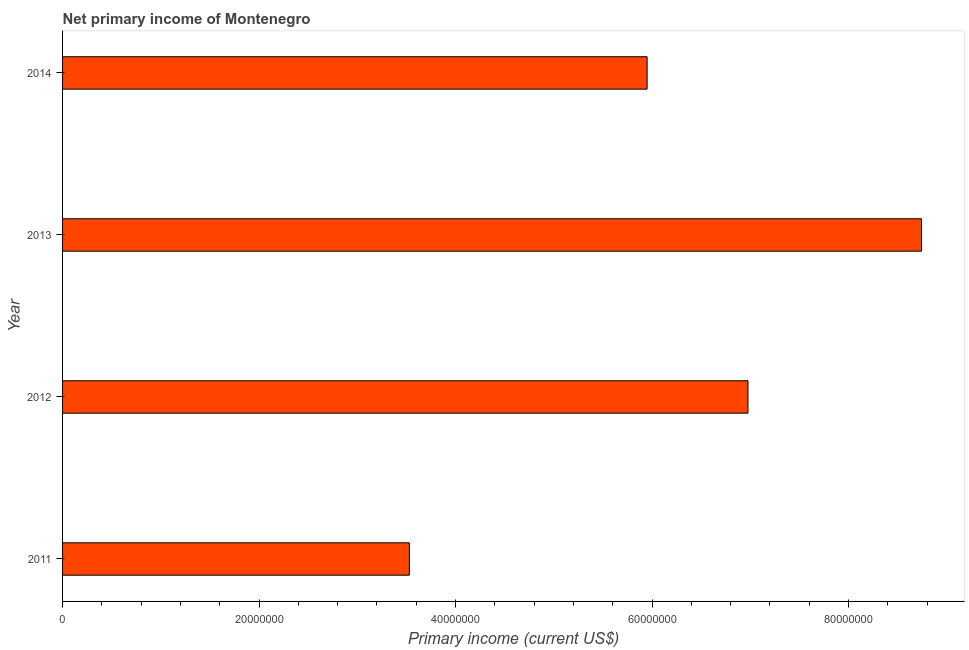What is the title of the graph?
Make the answer very short. Net primary income of Montenegro. What is the label or title of the X-axis?
Ensure brevity in your answer.  Primary income (current US$). What is the label or title of the Y-axis?
Make the answer very short. Year. What is the amount of primary income in 2013?
Give a very brief answer. 8.74e+07. Across all years, what is the maximum amount of primary income?
Your answer should be very brief. 8.74e+07. Across all years, what is the minimum amount of primary income?
Provide a succinct answer. 3.53e+07. What is the sum of the amount of primary income?
Offer a very short reply. 2.52e+08. What is the difference between the amount of primary income in 2012 and 2013?
Give a very brief answer. -1.77e+07. What is the average amount of primary income per year?
Provide a succinct answer. 6.30e+07. What is the median amount of primary income?
Keep it short and to the point. 6.46e+07. Do a majority of the years between 2013 and 2012 (inclusive) have amount of primary income greater than 68000000 US$?
Your response must be concise. No. What is the ratio of the amount of primary income in 2011 to that in 2012?
Offer a terse response. 0.51. Is the amount of primary income in 2011 less than that in 2014?
Provide a short and direct response. Yes. What is the difference between the highest and the second highest amount of primary income?
Offer a terse response. 1.77e+07. Is the sum of the amount of primary income in 2011 and 2013 greater than the maximum amount of primary income across all years?
Your response must be concise. Yes. What is the difference between the highest and the lowest amount of primary income?
Your response must be concise. 5.21e+07. What is the difference between two consecutive major ticks on the X-axis?
Provide a short and direct response. 2.00e+07. What is the Primary income (current US$) in 2011?
Ensure brevity in your answer.  3.53e+07. What is the Primary income (current US$) in 2012?
Ensure brevity in your answer.  6.98e+07. What is the Primary income (current US$) in 2013?
Give a very brief answer. 8.74e+07. What is the Primary income (current US$) in 2014?
Your response must be concise. 5.95e+07. What is the difference between the Primary income (current US$) in 2011 and 2012?
Your response must be concise. -3.45e+07. What is the difference between the Primary income (current US$) in 2011 and 2013?
Provide a succinct answer. -5.21e+07. What is the difference between the Primary income (current US$) in 2011 and 2014?
Your answer should be compact. -2.42e+07. What is the difference between the Primary income (current US$) in 2012 and 2013?
Make the answer very short. -1.77e+07. What is the difference between the Primary income (current US$) in 2012 and 2014?
Provide a short and direct response. 1.03e+07. What is the difference between the Primary income (current US$) in 2013 and 2014?
Give a very brief answer. 2.79e+07. What is the ratio of the Primary income (current US$) in 2011 to that in 2012?
Your answer should be very brief. 0.51. What is the ratio of the Primary income (current US$) in 2011 to that in 2013?
Provide a succinct answer. 0.4. What is the ratio of the Primary income (current US$) in 2011 to that in 2014?
Give a very brief answer. 0.59. What is the ratio of the Primary income (current US$) in 2012 to that in 2013?
Ensure brevity in your answer.  0.8. What is the ratio of the Primary income (current US$) in 2012 to that in 2014?
Offer a terse response. 1.17. What is the ratio of the Primary income (current US$) in 2013 to that in 2014?
Your response must be concise. 1.47. 